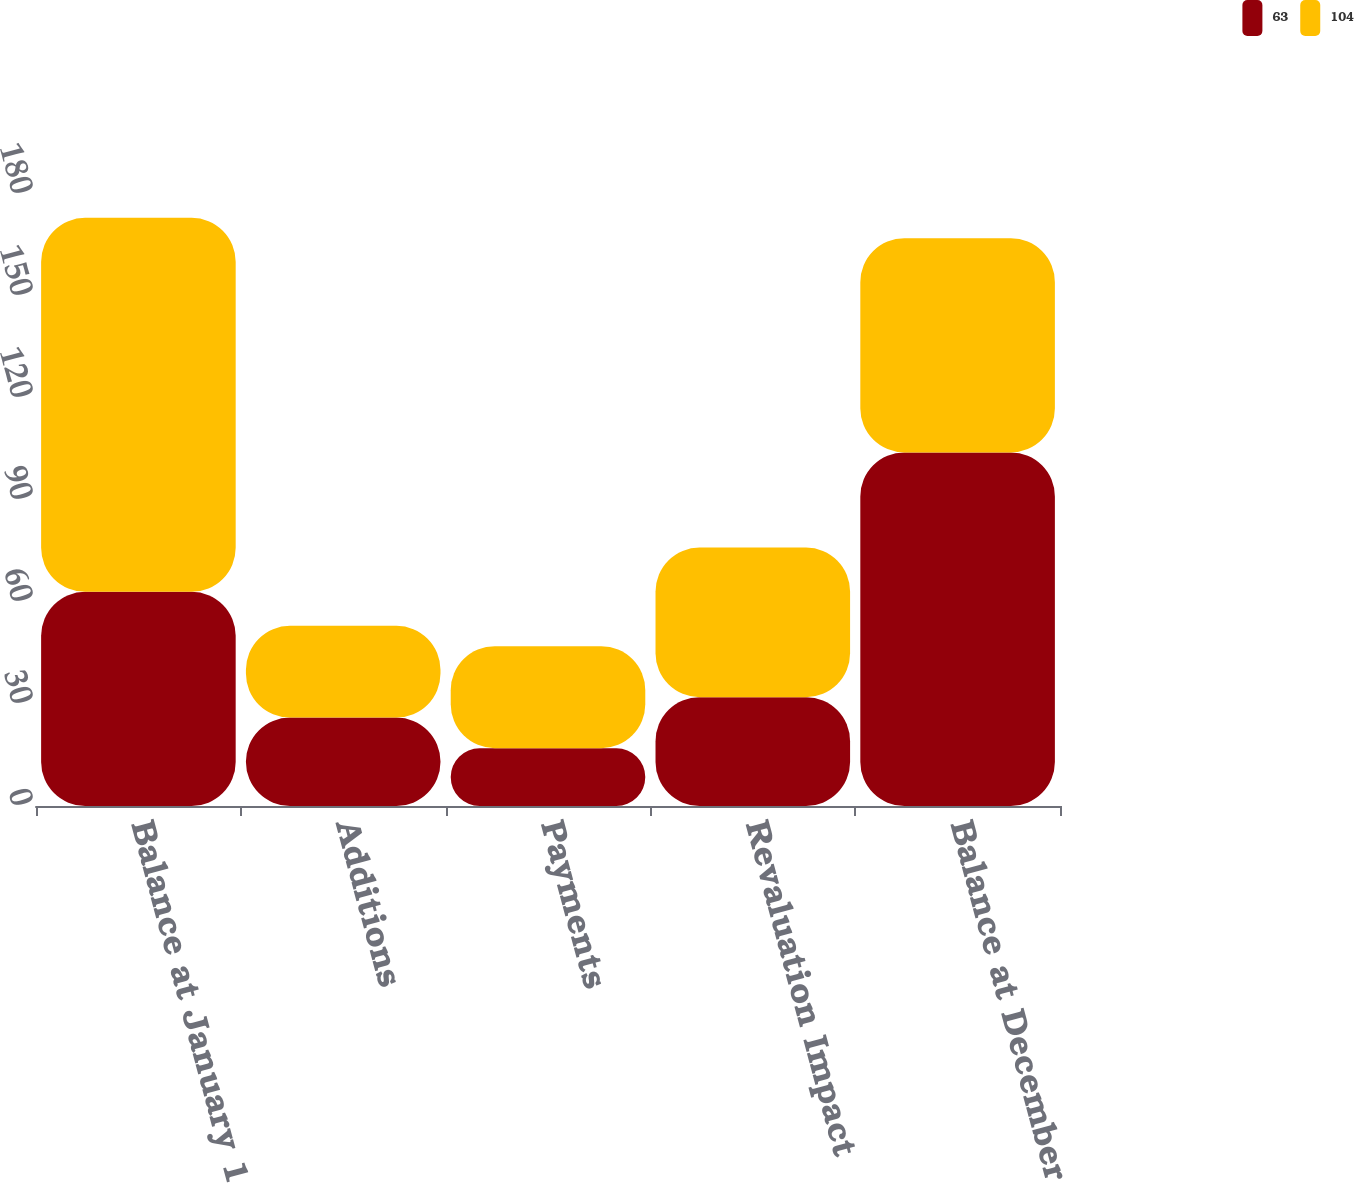Convert chart to OTSL. <chart><loc_0><loc_0><loc_500><loc_500><stacked_bar_chart><ecel><fcel>Balance at January 1<fcel>Additions<fcel>Payments<fcel>Revaluation Impact<fcel>Balance at December 31<nl><fcel>63<fcel>63<fcel>26<fcel>17<fcel>32<fcel>104<nl><fcel>104<fcel>110<fcel>27<fcel>30<fcel>44<fcel>63<nl></chart> 